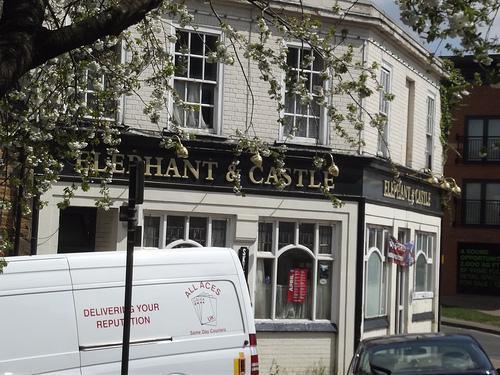How many cars are visible in the picture?
Give a very brief answer. 1. 